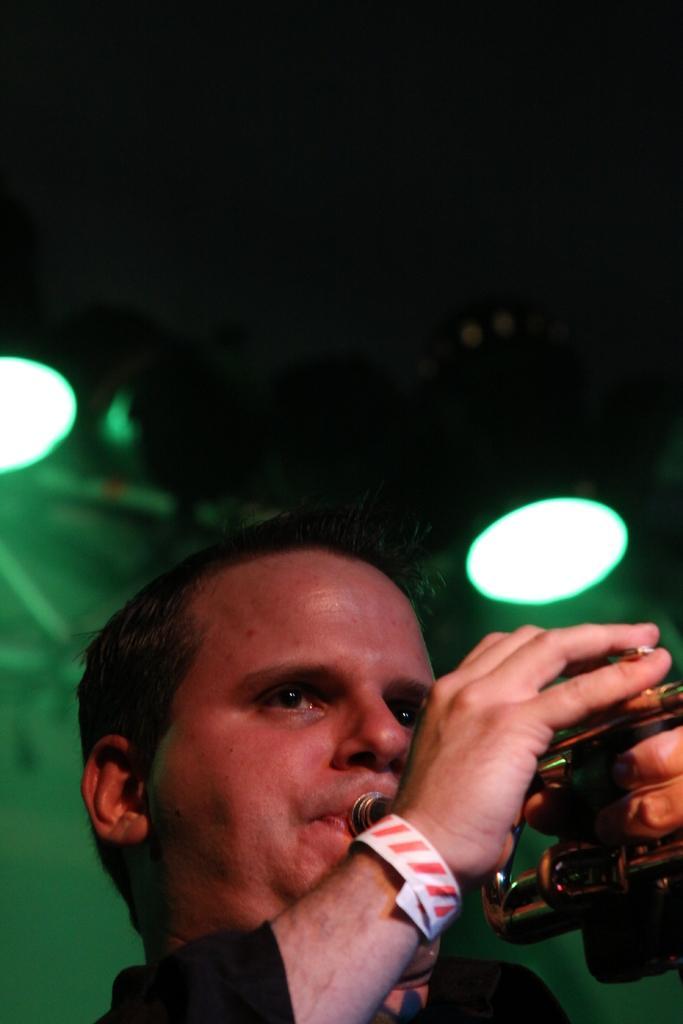How would you summarize this image in a sentence or two? In this image we can see a person wearing black color dress playing trumpet and at the background of the image there are some lights. 